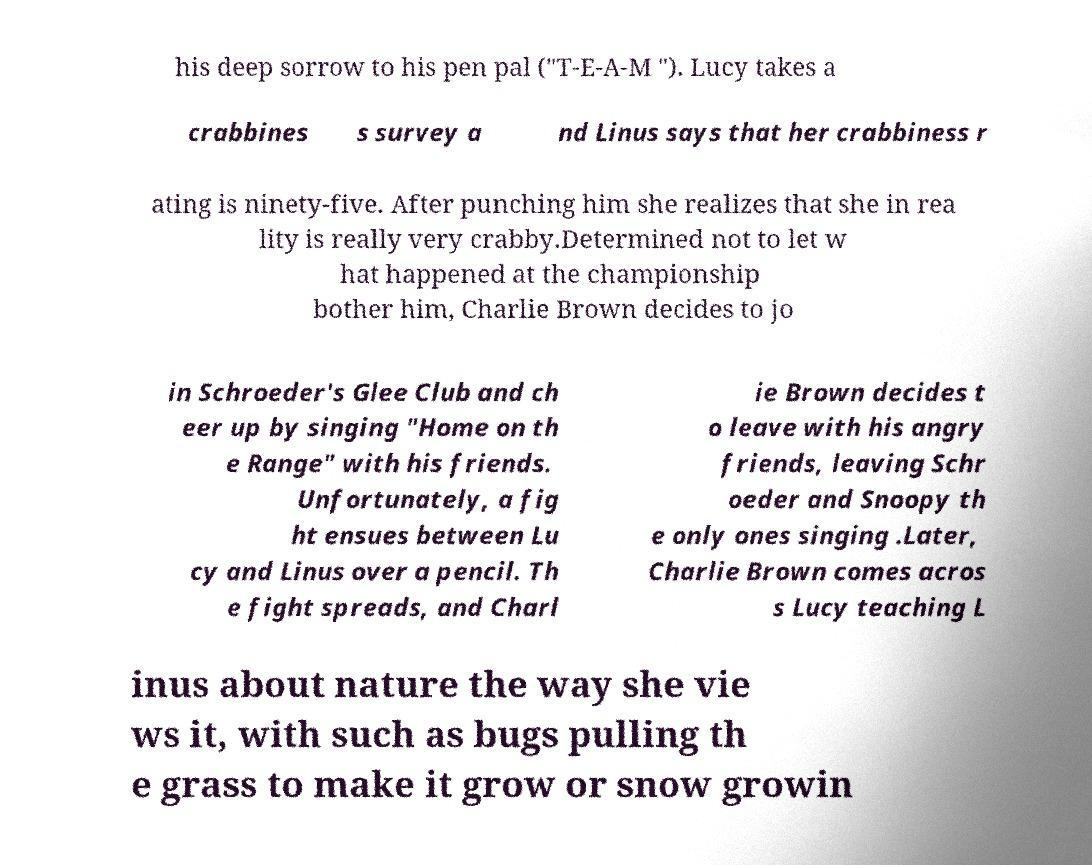Can you read and provide the text displayed in the image?This photo seems to have some interesting text. Can you extract and type it out for me? his deep sorrow to his pen pal ("T-E-A-M "). Lucy takes a crabbines s survey a nd Linus says that her crabbiness r ating is ninety-five. After punching him she realizes that she in rea lity is really very crabby.Determined not to let w hat happened at the championship bother him, Charlie Brown decides to jo in Schroeder's Glee Club and ch eer up by singing "Home on th e Range" with his friends. Unfortunately, a fig ht ensues between Lu cy and Linus over a pencil. Th e fight spreads, and Charl ie Brown decides t o leave with his angry friends, leaving Schr oeder and Snoopy th e only ones singing .Later, Charlie Brown comes acros s Lucy teaching L inus about nature the way she vie ws it, with such as bugs pulling th e grass to make it grow or snow growin 